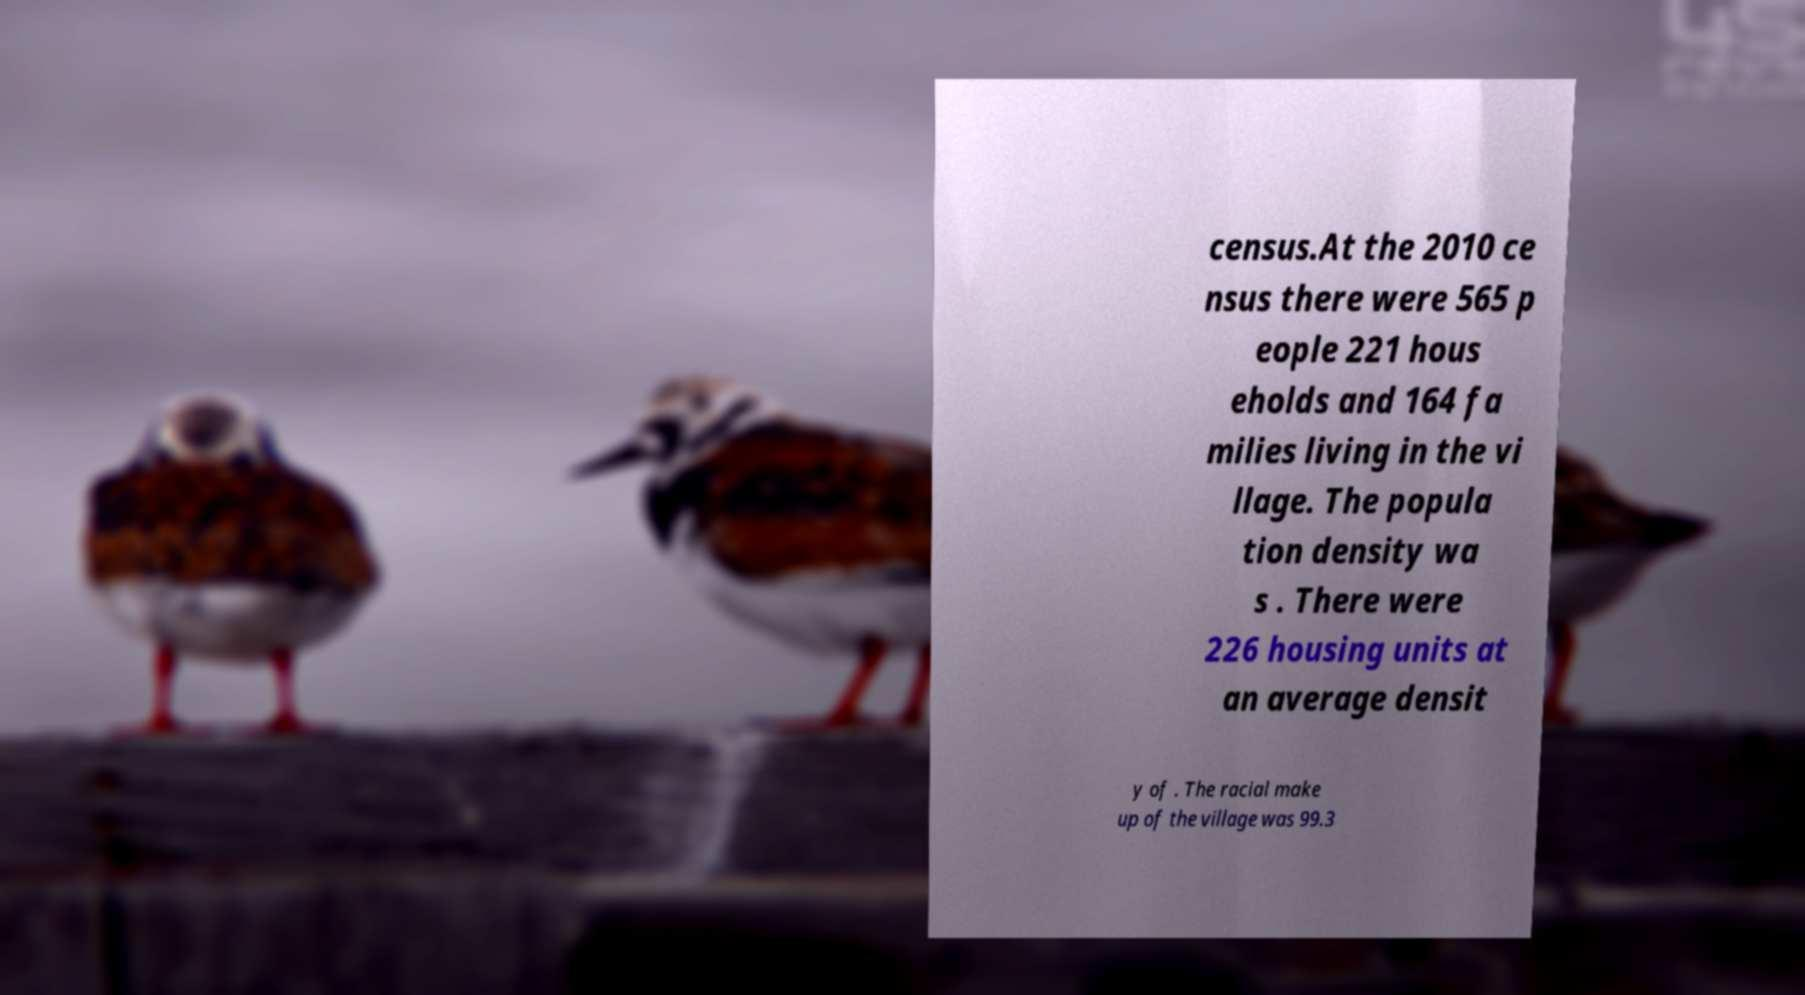Could you extract and type out the text from this image? census.At the 2010 ce nsus there were 565 p eople 221 hous eholds and 164 fa milies living in the vi llage. The popula tion density wa s . There were 226 housing units at an average densit y of . The racial make up of the village was 99.3 